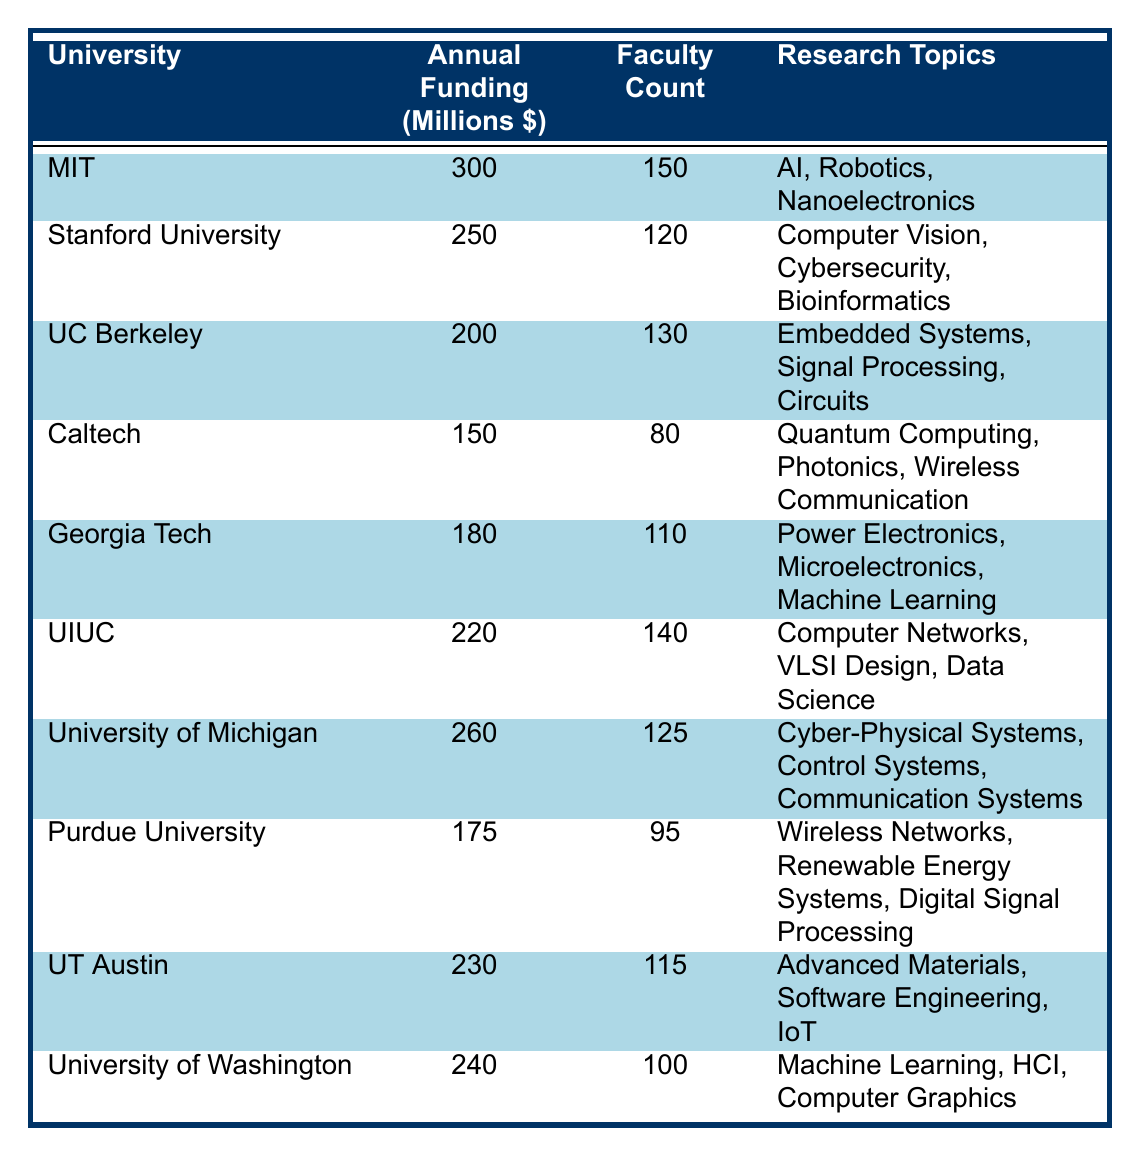What university has the highest annual research funding? By scanning through the table, Massachusetts Institute of Technology (MIT) has the highest funding amount listed as 300 million dollars.
Answer: MIT What is the annual research funding of Purdue University? The table shows that Purdue University has an annual research funding allocation of 175 million dollars.
Answer: 175 million dollars Which university has the lowest faculty count among the listed universities? California Institute of Technology (Caltech) is highlighted in the table with a faculty count of 80, which is the lowest compared to others.
Answer: 80 How many universities have annual research funding above 200 million dollars? By reviewing the table, the universities with funding above 200 million dollars are MIT (300), Stanford (250), University of Michigan (260), and University of Texas at Austin (230). This accounts for a total of 4 universities.
Answer: 4 What is the total annual research funding of all universities combined? Adding the funding amounts from the table: 300 + 250 + 200 + 150 + 180 + 220 + 260 + 175 + 230 + 240 = 1965 million dollars in total.
Answer: 1965 million dollars What percentage of faculty at the University of Illinois at Urbana-Champaign are supported by research funding of 220 million dollars? To find the percentage, divide the faculty count (140) by the funding amount (220), then multiply by 100. However, because this is a mixed measure, it's better to state it's supportive to one faculty per funding amount. The exact percentage is not directly applicable.
Answer: Not directly applicable Is the research topic "Machine Learning" part of the curriculum in Purdue University? Checking the table, "Machine Learning" is listed as a research topic at University of Georgia Institute of Technology and University of Washington, but not for Purdue University, meaning it is not part of Purdue's curriculum.
Answer: No Which university has an annual research funding closest to 200 million dollars? Looking at the funding amounts, Georgia Institute of Technology has 180 million dollars, which is the nearest value to 200 million dollars compared to others.
Answer: Georgia Institute of Technology What is the average annual research funding across the listed universities? Summing the funding amounts gives a total of 1965 million dollars, and dividing it by the number of universities (10) yields an average of 196.5 million dollars.
Answer: 196.5 million dollars Which two universities have similar faculty counts, and what are their counts? Scanning through the table, University of California, Berkeley has 130 faculty, and University of Illinois at Urbana-Champaign has 140 faculty, showing they have relatively similar counts.
Answer: UC Berkeley: 130, UIUC: 140 